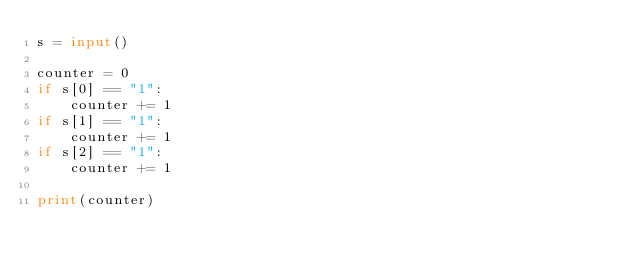<code> <loc_0><loc_0><loc_500><loc_500><_Python_>s = input()

counter = 0
if s[0] == "1":
    counter += 1
if s[1] == "1":
    counter += 1
if s[2] == "1":
    counter += 1

print(counter)
</code> 